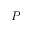Convert formula to latex. <formula><loc_0><loc_0><loc_500><loc_500>P</formula> 